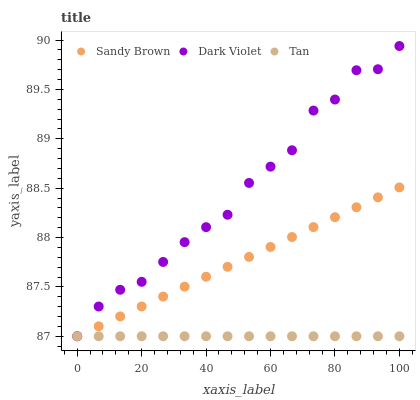Does Tan have the minimum area under the curve?
Answer yes or no. Yes. Does Dark Violet have the maximum area under the curve?
Answer yes or no. Yes. Does Sandy Brown have the minimum area under the curve?
Answer yes or no. No. Does Sandy Brown have the maximum area under the curve?
Answer yes or no. No. Is Sandy Brown the smoothest?
Answer yes or no. Yes. Is Dark Violet the roughest?
Answer yes or no. Yes. Is Dark Violet the smoothest?
Answer yes or no. No. Is Sandy Brown the roughest?
Answer yes or no. No. Does Tan have the lowest value?
Answer yes or no. Yes. Does Dark Violet have the highest value?
Answer yes or no. Yes. Does Sandy Brown have the highest value?
Answer yes or no. No. Does Sandy Brown intersect Tan?
Answer yes or no. Yes. Is Sandy Brown less than Tan?
Answer yes or no. No. Is Sandy Brown greater than Tan?
Answer yes or no. No. 